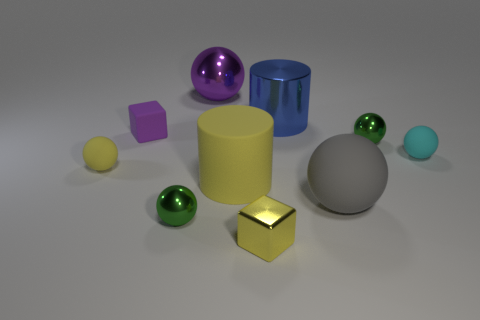Which objects in the image appear to be reflective, and why might that be? The objects that appear reflective are the small green sphere, the shiny metallic cube, and slightly the large grey sphere. These appear reflective due to the way they interact with the light, suggesting materials like polished metal, glass, or other glossy surfaces that can mirror their environment. This reflectivity can indicate qualities about the material's smoothness and potential real-world use, as reflective surfaces are often used for decorative or functional purposes where visibility is key. 